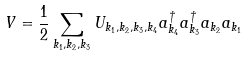Convert formula to latex. <formula><loc_0><loc_0><loc_500><loc_500>V = \frac { 1 } { 2 } \sum _ { { k } _ { 1 } , { k } _ { 2 } , { k } _ { 3 } } U _ { { k } _ { 1 } , { k } _ { 2 } , { k } _ { 3 } , { k } _ { 4 } } a ^ { \dagger } _ { { k } _ { 4 } } a ^ { \dagger } _ { { k } _ { 3 } } a _ { { k } _ { 2 } } a _ { { k } _ { 1 } }</formula> 